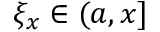Convert formula to latex. <formula><loc_0><loc_0><loc_500><loc_500>\xi _ { x } \in ( a , x ]</formula> 